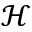Convert formula to latex. <formula><loc_0><loc_0><loc_500><loc_500>\mathcal { H }</formula> 